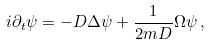Convert formula to latex. <formula><loc_0><loc_0><loc_500><loc_500>i \partial _ { t } \psi = - D \Delta \psi + { \frac { 1 } { 2 m D } } \Omega \psi \, ,</formula> 